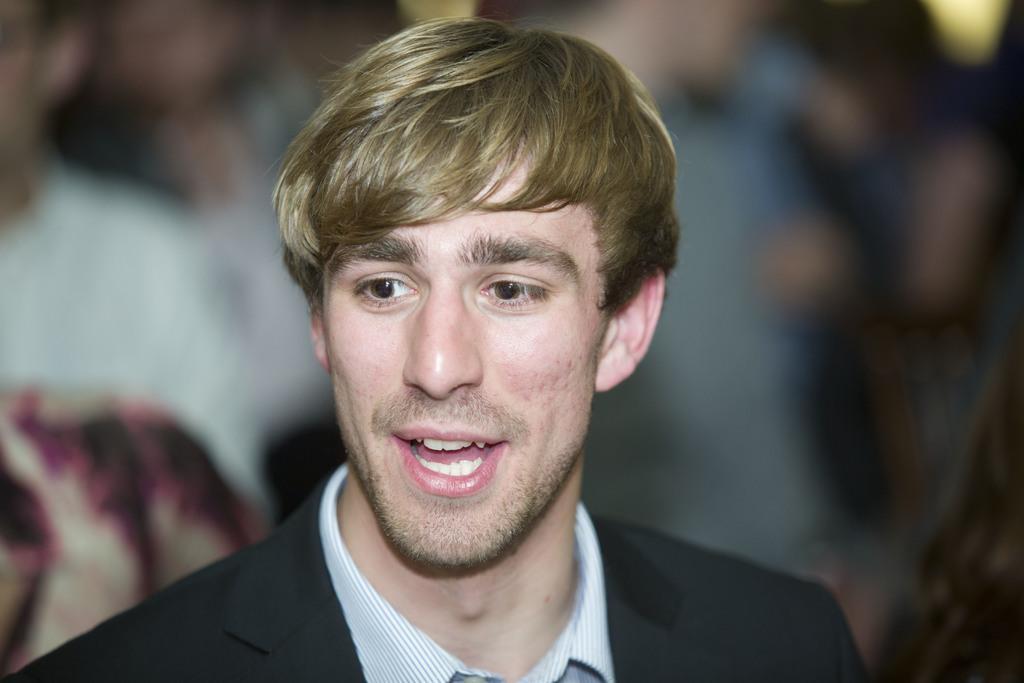Could you give a brief overview of what you see in this image? In the picture we can see a man standing and he is smiling, wearing a black color blazer, in the background we can see some people. 